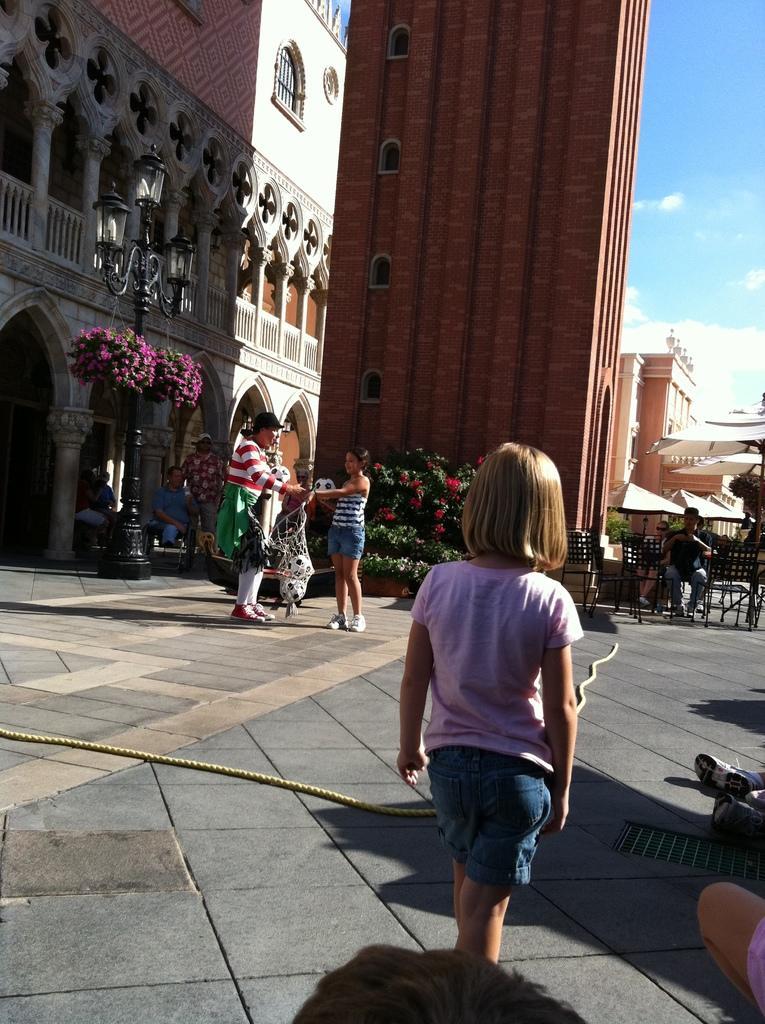In one or two sentences, can you explain what this image depicts? In this picture we can see buildings in the background, there are two persons standing here, on the left side there is a pole and lights, we can see some flowers here, on the right side there are some chairs, we can see the sky at the right top of the picture. 